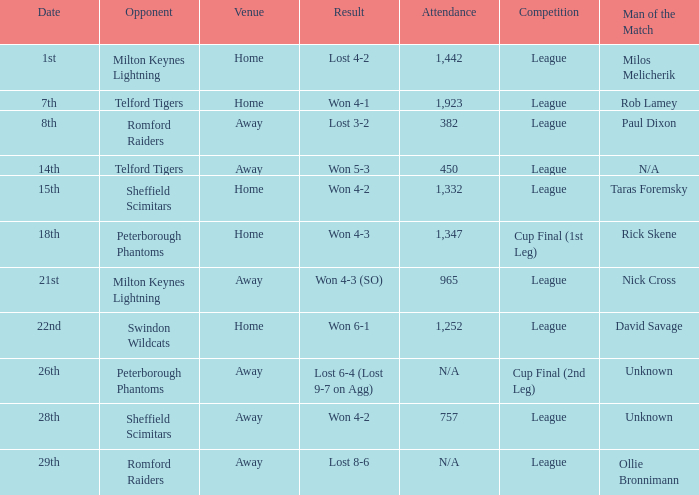What was the date when the match at the away venue resulted in a 6-4 loss (9-7 defeat on aggregate)? 26th. 